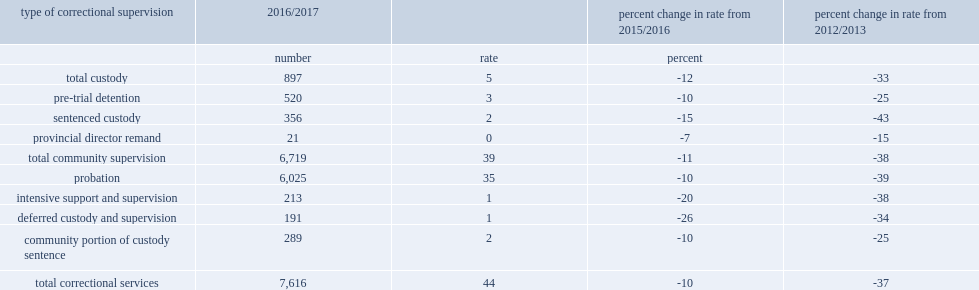In 2016/2017, how many ,on an average day, youth supervised in custody or a community program in the 10 reporting jurisdictions? 7616.0. What is the number of total correctional services represent a rate per 10,000 youth population? 44.0. Total correctional services represent a rate of 44 per 10,000 youth population, how many percent of decreasing from the previous year? 10. Total correctional services represent a rate of 44 per 10,000 youth population, how many percent of decreasing from 2012/2013? 37. On an average day in 2016/2017, how many youth in custody in the 12 reporting jurisdictions? 897.0. On an average day in 2016/2017, there were 897 youth in custody in the 12 reporting jurisdictions, what was the rate of representing per 10,000 youth population? 5.0. On an average day in 2016/2017, there were 897 youth in custody in the 12 reporting jurisdictions, how many percent of decrease from the previous year representing? 12. On an average day in 2016/2017, there were 897 youth in custody in the 12 reporting jurisdictions, how many percent of representing decrease from 2012/2013? 33. 